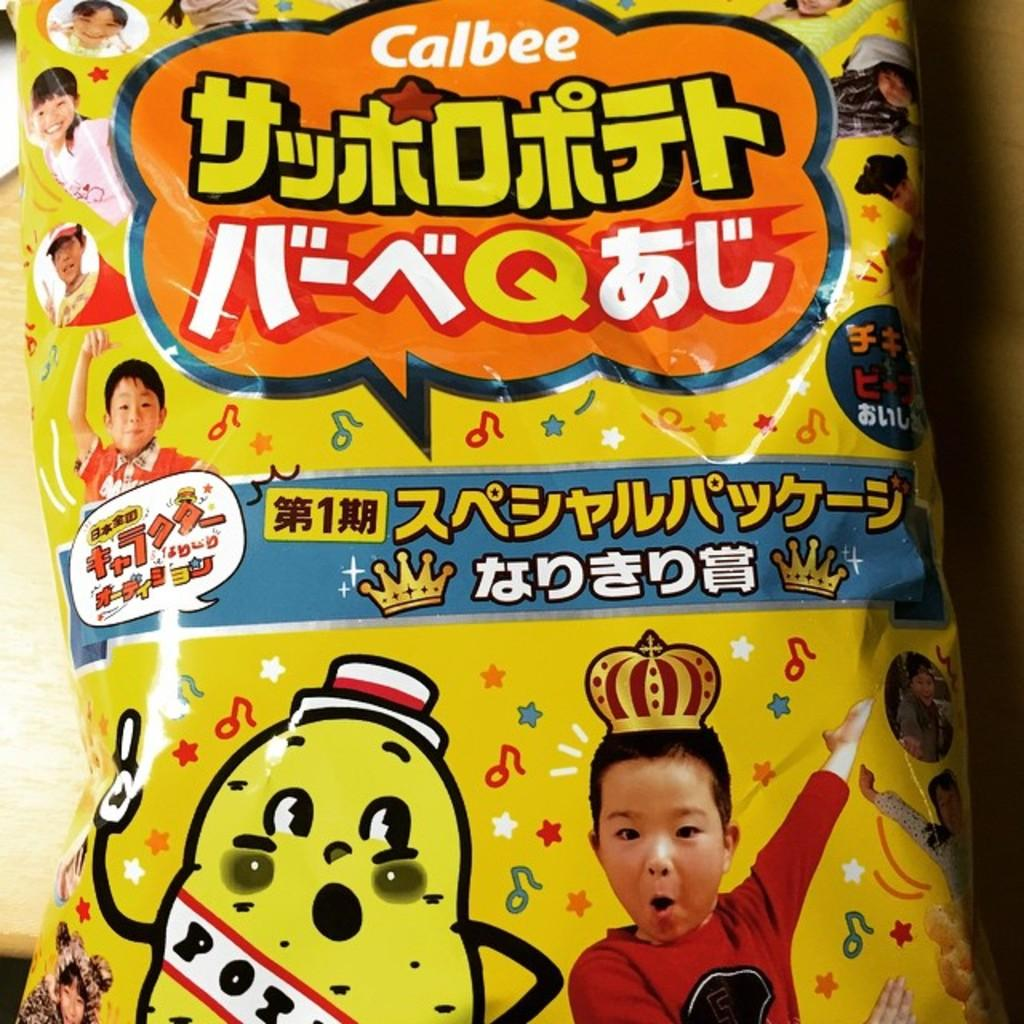What is present on the platform in the image? There is a packet on the platform in the image. What can be seen on the packet? The packet has pictures of persons and cartoon images on it. Are there any words or phrases written on the packet? Yes, there are texts written on the packet. Is there any oil dripping from the packet in the image? There is no oil present in the image, nor is there any indication of oil dripping from the packet. 